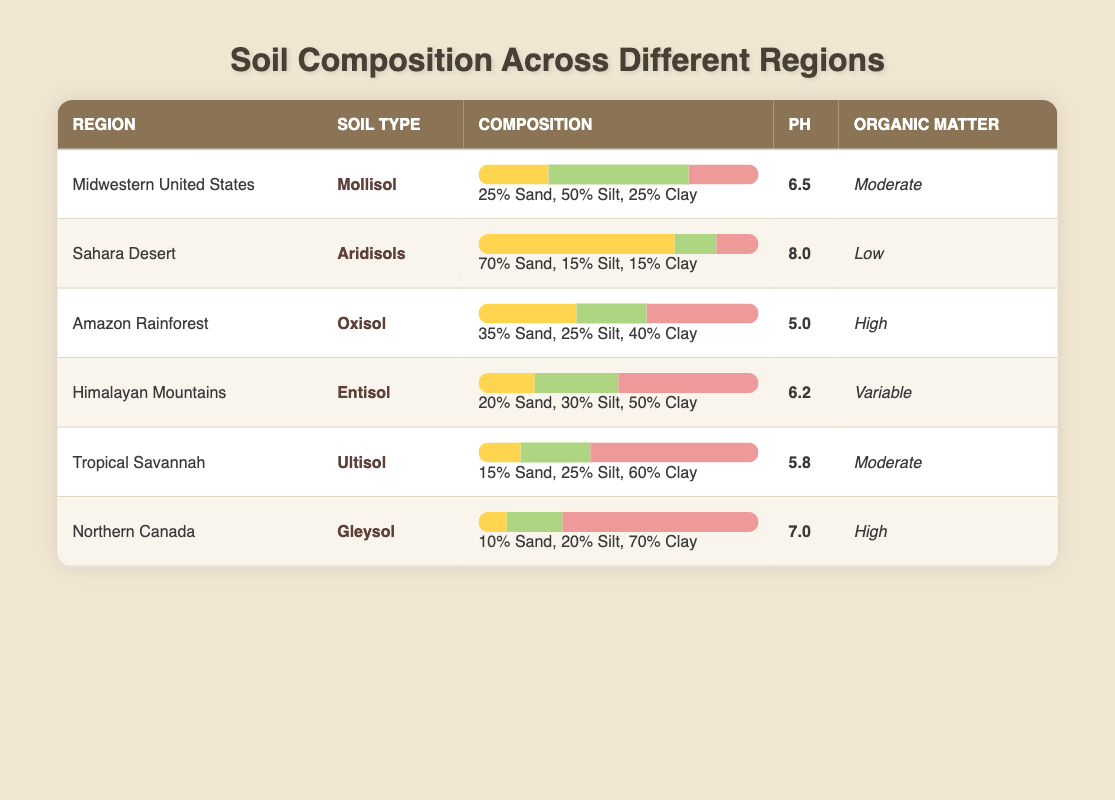What soil type is found in the Amazon Rainforest? According to the table, the soil type listed for the Amazon Rainforest is "Oxisol."
Answer: Oxisol Which region has the highest sand percentage? By examining the sand percentages in the table, the Sahara Desert has the highest sand content at 70%.
Answer: Sahara Desert Is the organic matter in Tropical Savannah soil moderate? The table indicates that the organic matter in Tropical Savannah is labeled as "Moderate," confirming the statement is true.
Answer: Yes What is the average pH of the soils in Midwestern United States and Northern Canada? The pH values for Midwestern United States and Northern Canada are 6.5 and 7.0, respectively. To find the average, we sum these values (6.5 + 7.0) = 13.5 and divide by 2 to get 13.5 / 2 = 6.75.
Answer: 6.75 Which soil type has the lowest organic matter, and what is its pH? The lowest organic matter recorded in the table is "Low," found in the Sahara Desert, which has a pH of 8.0.
Answer: Aridisols, 8.0 What is the composition of the soil in terms of sand, silt, and clay for the Northern Canada region? The table details that Northern Canada has 10% sand, 20% silt, and 70% clay. These values can be directly retrieved from the corresponding row in the table for Northern Canada.
Answer: 10% Sand, 20% Silt, 70% Clay Is the clay percentage in Himalayan Mountains higher than that in Tropical Savannah? The clay percentage in Himalayan Mountains is 50%, while in Tropical Savannah, it is 60%. Since 50% is less than 60%, the statement is false.
Answer: No What is the difference in percentage of silt between Mollisol and Gleysol? Mollisol has 50% silt, while Gleysol has 20%. The difference is calculated as: 50% - 20% = 30%.
Answer: 30% Which region’s soil type has a variable organic matter content? In the table, the Himalayan Mountains are noted for having a "Variable" organic matter content listed in the corresponding row.
Answer: Himalayan Mountains 